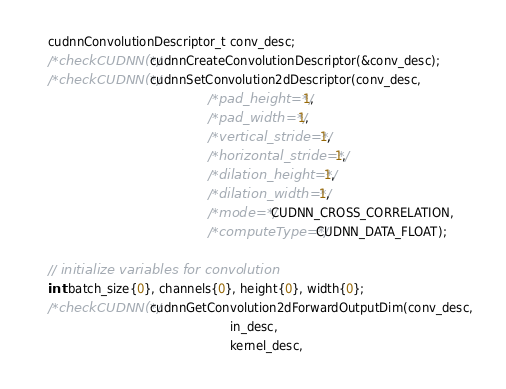<code> <loc_0><loc_0><loc_500><loc_500><_Cuda_>    cudnnConvolutionDescriptor_t conv_desc;
    /*checkCUDNN(*/cudnnCreateConvolutionDescriptor(&conv_desc);
    /*checkCUDNN(*/cudnnSetConvolution2dDescriptor(conv_desc,
                                               /*pad_height=*/1,
                                               /*pad_width=*/1,
                                               /*vertical_stride=*/1,
                                               /*horizontal_stride=*/1,
                                               /*dilation_height=*/1,
                                               /*dilation_width=*/1,
                                               /*mode=*/CUDNN_CROSS_CORRELATION,
                                               /*computeType=*/CUDNN_DATA_FLOAT);

    // initialize variables for convolution
    int batch_size{0}, channels{0}, height{0}, width{0};
    /*checkCUDNN(*/cudnnGetConvolution2dForwardOutputDim(conv_desc,
                                                     in_desc,
                                                     kernel_desc,</code> 